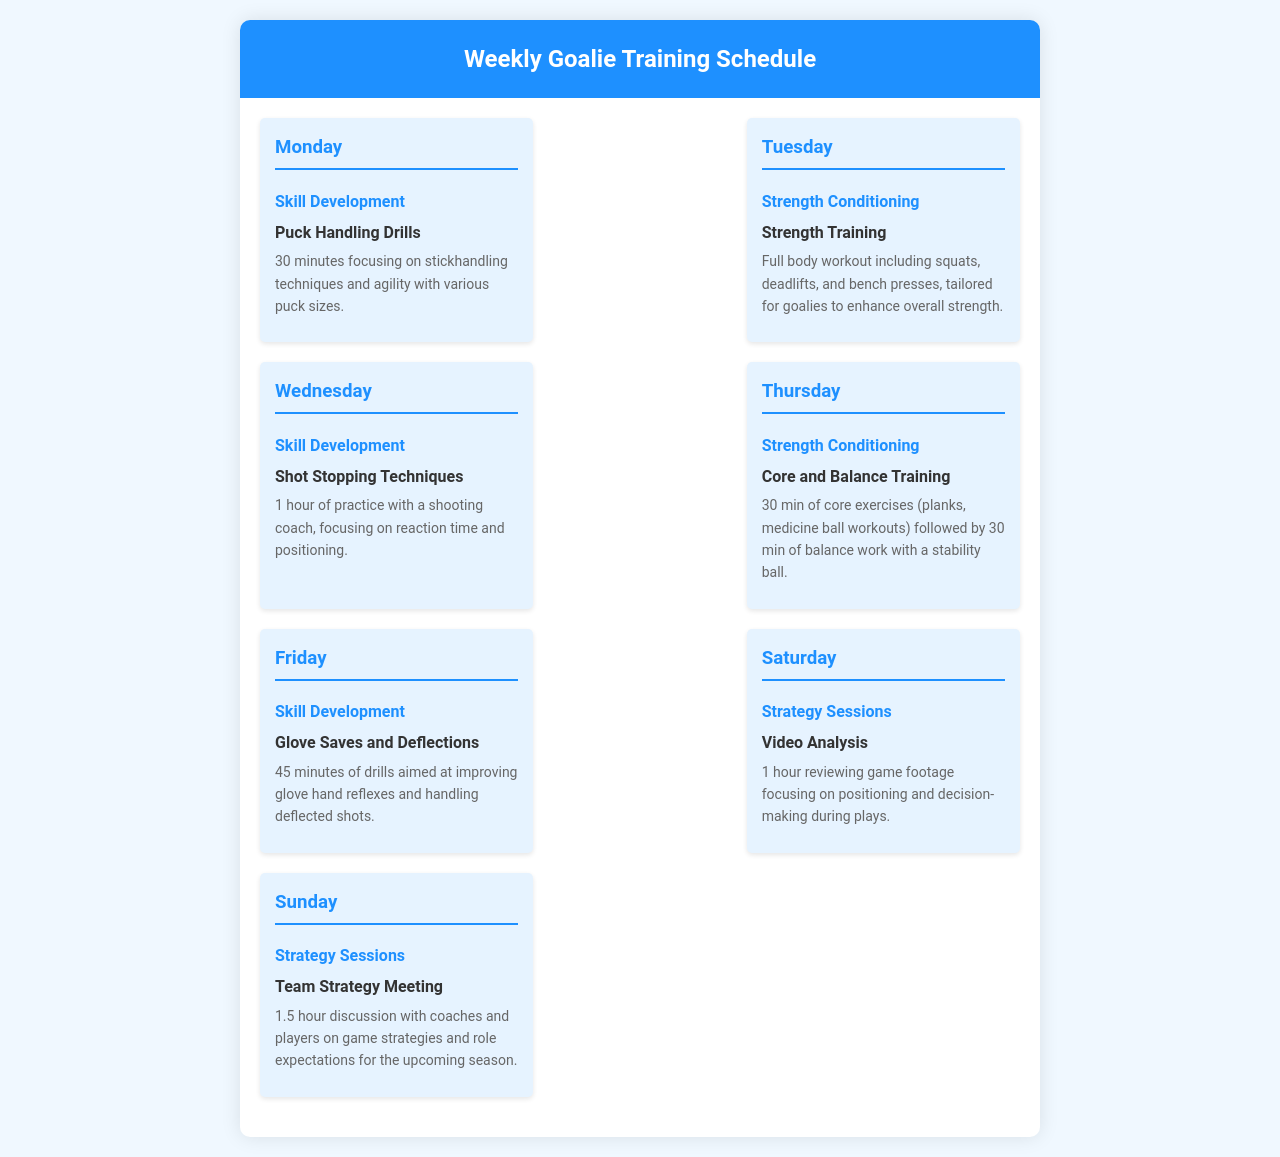What is scheduled for Monday? The document outlines that Monday's focus is on Skill Development with Puck Handling Drills.
Answer: Puck Handling Drills How long is the Strength Training session on Tuesday? The session on Tuesday focuses on Strength Conditioning and is described as a full body workout, typically lasting longer than a single activity, but the duration is not explicitly mentioned.
Answer: Not specified What skill will be practiced on Wednesday? Wednesday is dedicated to Shot Stopping Techniques, a specific skill development activity.
Answer: Shot Stopping Techniques How many hours is the video analysis session on Saturday? The document indicates that the Video Analysis session on Saturday lasts for 1 hour.
Answer: 1 hour What type of training is emphasized on Thursday? Thursday's focus is on Strength Conditioning, which includes core and balance training.
Answer: Strength Conditioning What is the duration of the Team Strategy Meeting on Sunday? The duration of the Team Strategy Meeting is outlined as 1.5 hours.
Answer: 1.5 hours Which activity includes discussion on role expectations for the upcoming season? The Team Strategy Meeting on Sunday includes discussions on game strategies and role expectations.
Answer: Team Strategy Meeting What focus area does the Friday activity belong to? The activity on Friday is focused on Skill Development, particularly enhancing glove hand reflexes.
Answer: Skill Development Which day focuses on Core and Balance Training? The day that focuses on Core and Balance Training is Thursday.
Answer: Thursday 